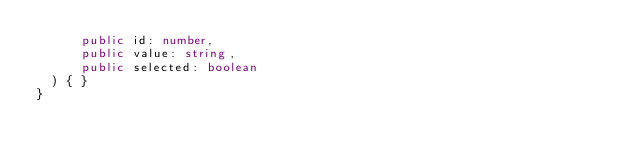Convert code to text. <code><loc_0><loc_0><loc_500><loc_500><_TypeScript_>      public id: number,
      public value: string,
      public selected: boolean
  ) { }
}
</code> 